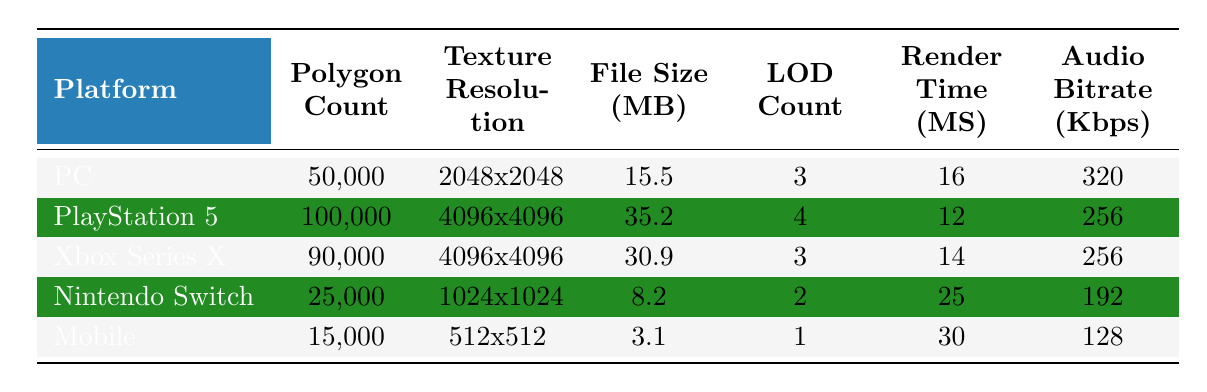What is the polygon count for the Xbox Series X asset? The table lists the polygon count specifically for the Xbox Series X under the "Polygon Count" column, which states it as 90,000.
Answer: 90,000 Which platform has the highest file size for a 3D Model asset? By comparing the "File Size (MB)" column, the PlayStation 5 has the highest file size at 35.2 MB, as all other platforms have lower values.
Answer: PlayStation 5 What is the average render time for the Nintendo Switch and Mobile platforms? The render times for Nintendo Switch and Mobile are 25 ms and 30 ms, respectively. Adding these gives 55 ms, and dividing by 2 yields an average of 27.5 ms.
Answer: 27.5 Does the PC asset have a texture resolution lower than 4096x4096? The texture resolution for the PC asset is 2048x2048, which is indeed lower than 4096x4096 stated for both PlayStation 5 and Xbox Series X.
Answer: Yes Which platform has the lowest audio bitrate? By examining the "Audio Bitrate (Kbps)" column, Mobile has the lowest bitrate at 128 Kbps compared to others that have higher values.
Answer: Mobile 